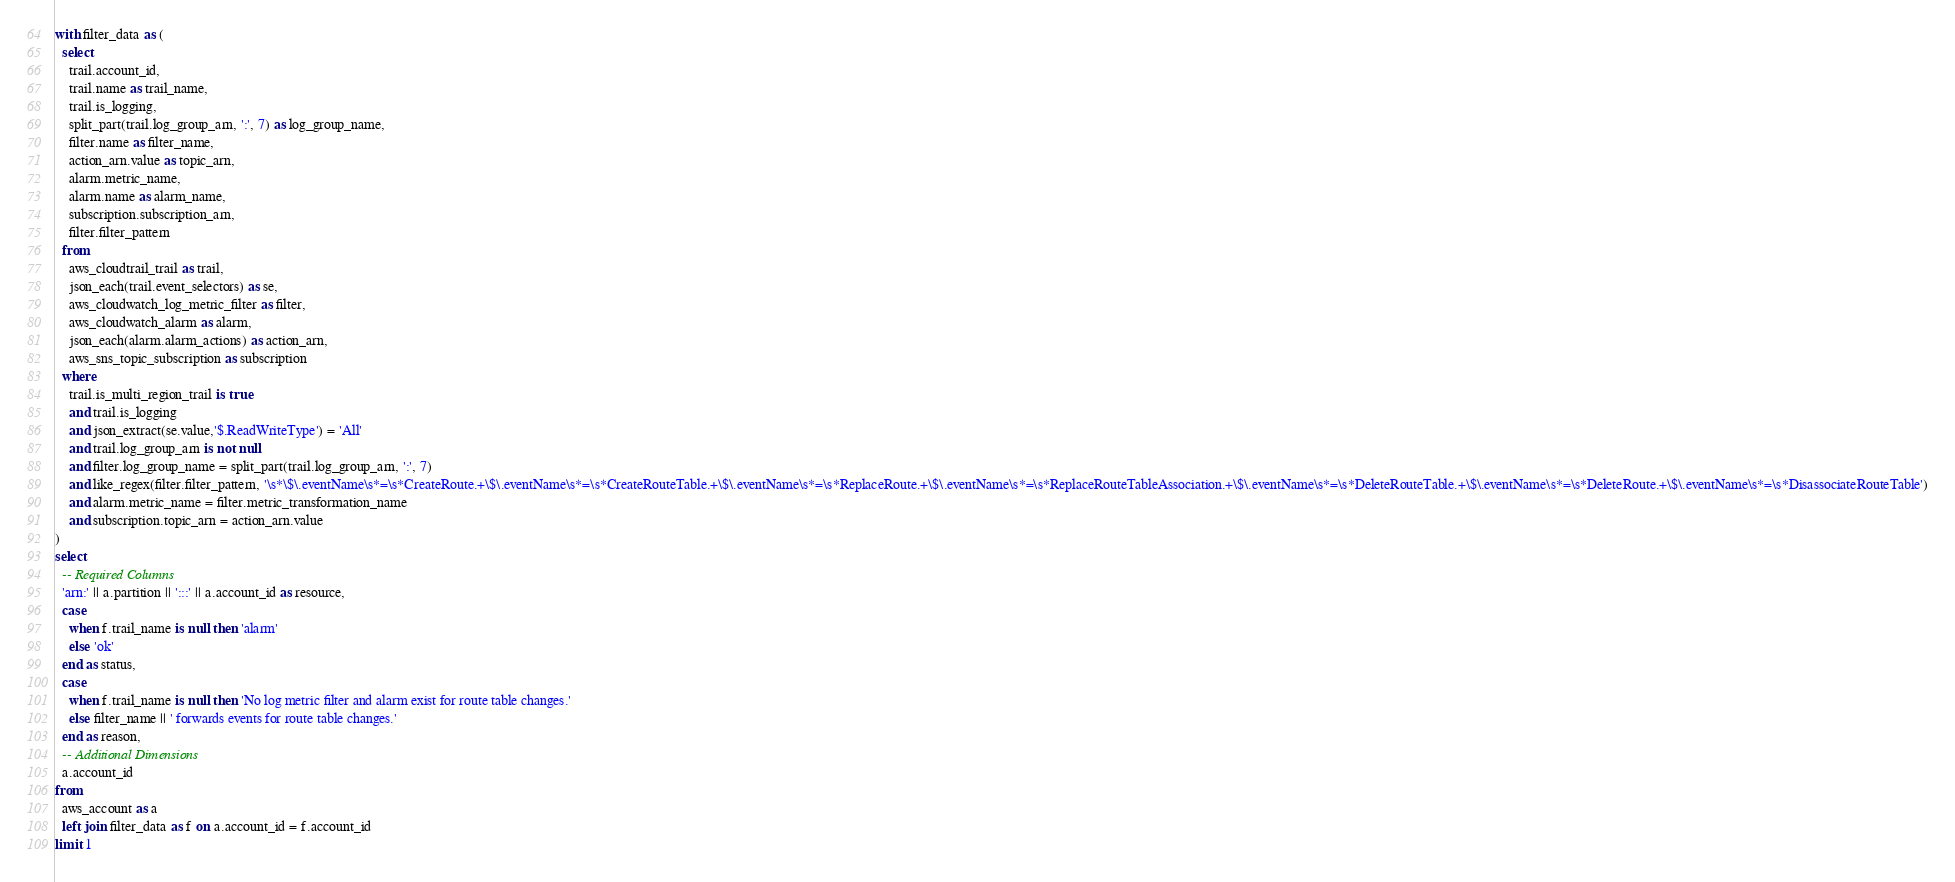Convert code to text. <code><loc_0><loc_0><loc_500><loc_500><_SQL_>with filter_data as (
  select
    trail.account_id,
    trail.name as trail_name,
    trail.is_logging,
    split_part(trail.log_group_arn, ':', 7) as log_group_name,
    filter.name as filter_name,
    action_arn.value as topic_arn,
    alarm.metric_name,
    alarm.name as alarm_name,
    subscription.subscription_arn,
    filter.filter_pattern
  from
    aws_cloudtrail_trail as trail,
    json_each(trail.event_selectors) as se,
    aws_cloudwatch_log_metric_filter as filter,
    aws_cloudwatch_alarm as alarm,
    json_each(alarm.alarm_actions) as action_arn,
    aws_sns_topic_subscription as subscription
  where
    trail.is_multi_region_trail is true
    and trail.is_logging
    and json_extract(se.value,'$.ReadWriteType') = 'All'
    and trail.log_group_arn is not null
    and filter.log_group_name = split_part(trail.log_group_arn, ':', 7)
    and like_regex(filter.filter_pattern, '\s*\$\.eventName\s*=\s*CreateRoute.+\$\.eventName\s*=\s*CreateRouteTable.+\$\.eventName\s*=\s*ReplaceRoute.+\$\.eventName\s*=\s*ReplaceRouteTableAssociation.+\$\.eventName\s*=\s*DeleteRouteTable.+\$\.eventName\s*=\s*DeleteRoute.+\$\.eventName\s*=\s*DisassociateRouteTable')
    and alarm.metric_name = filter.metric_transformation_name
    and subscription.topic_arn = action_arn.value
)
select
  -- Required Columns
  'arn:' || a.partition || ':::' || a.account_id as resource,
  case
    when f.trail_name is null then 'alarm'
    else 'ok'
  end as status,
  case
    when f.trail_name is null then 'No log metric filter and alarm exist for route table changes.'
    else filter_name || ' forwards events for route table changes.'
  end as reason,
  -- Additional Dimensions
  a.account_id
from
  aws_account as a
  left join filter_data as f on a.account_id = f.account_id
limit 1
</code> 